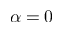Convert formula to latex. <formula><loc_0><loc_0><loc_500><loc_500>\alpha = 0</formula> 